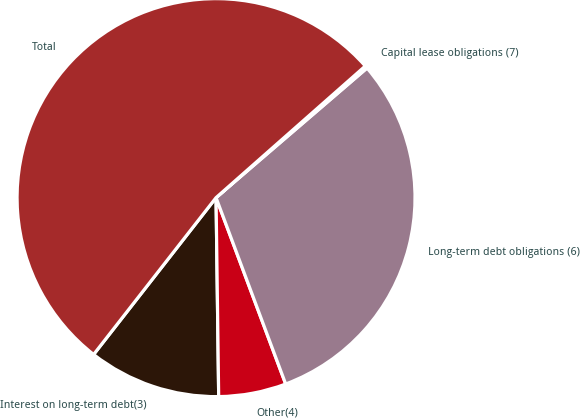Convert chart to OTSL. <chart><loc_0><loc_0><loc_500><loc_500><pie_chart><fcel>Interest on long-term debt(3)<fcel>Other(4)<fcel>Long-term debt obligations (6)<fcel>Capital lease obligations (7)<fcel>Total<nl><fcel>10.76%<fcel>5.48%<fcel>30.6%<fcel>0.21%<fcel>52.95%<nl></chart> 